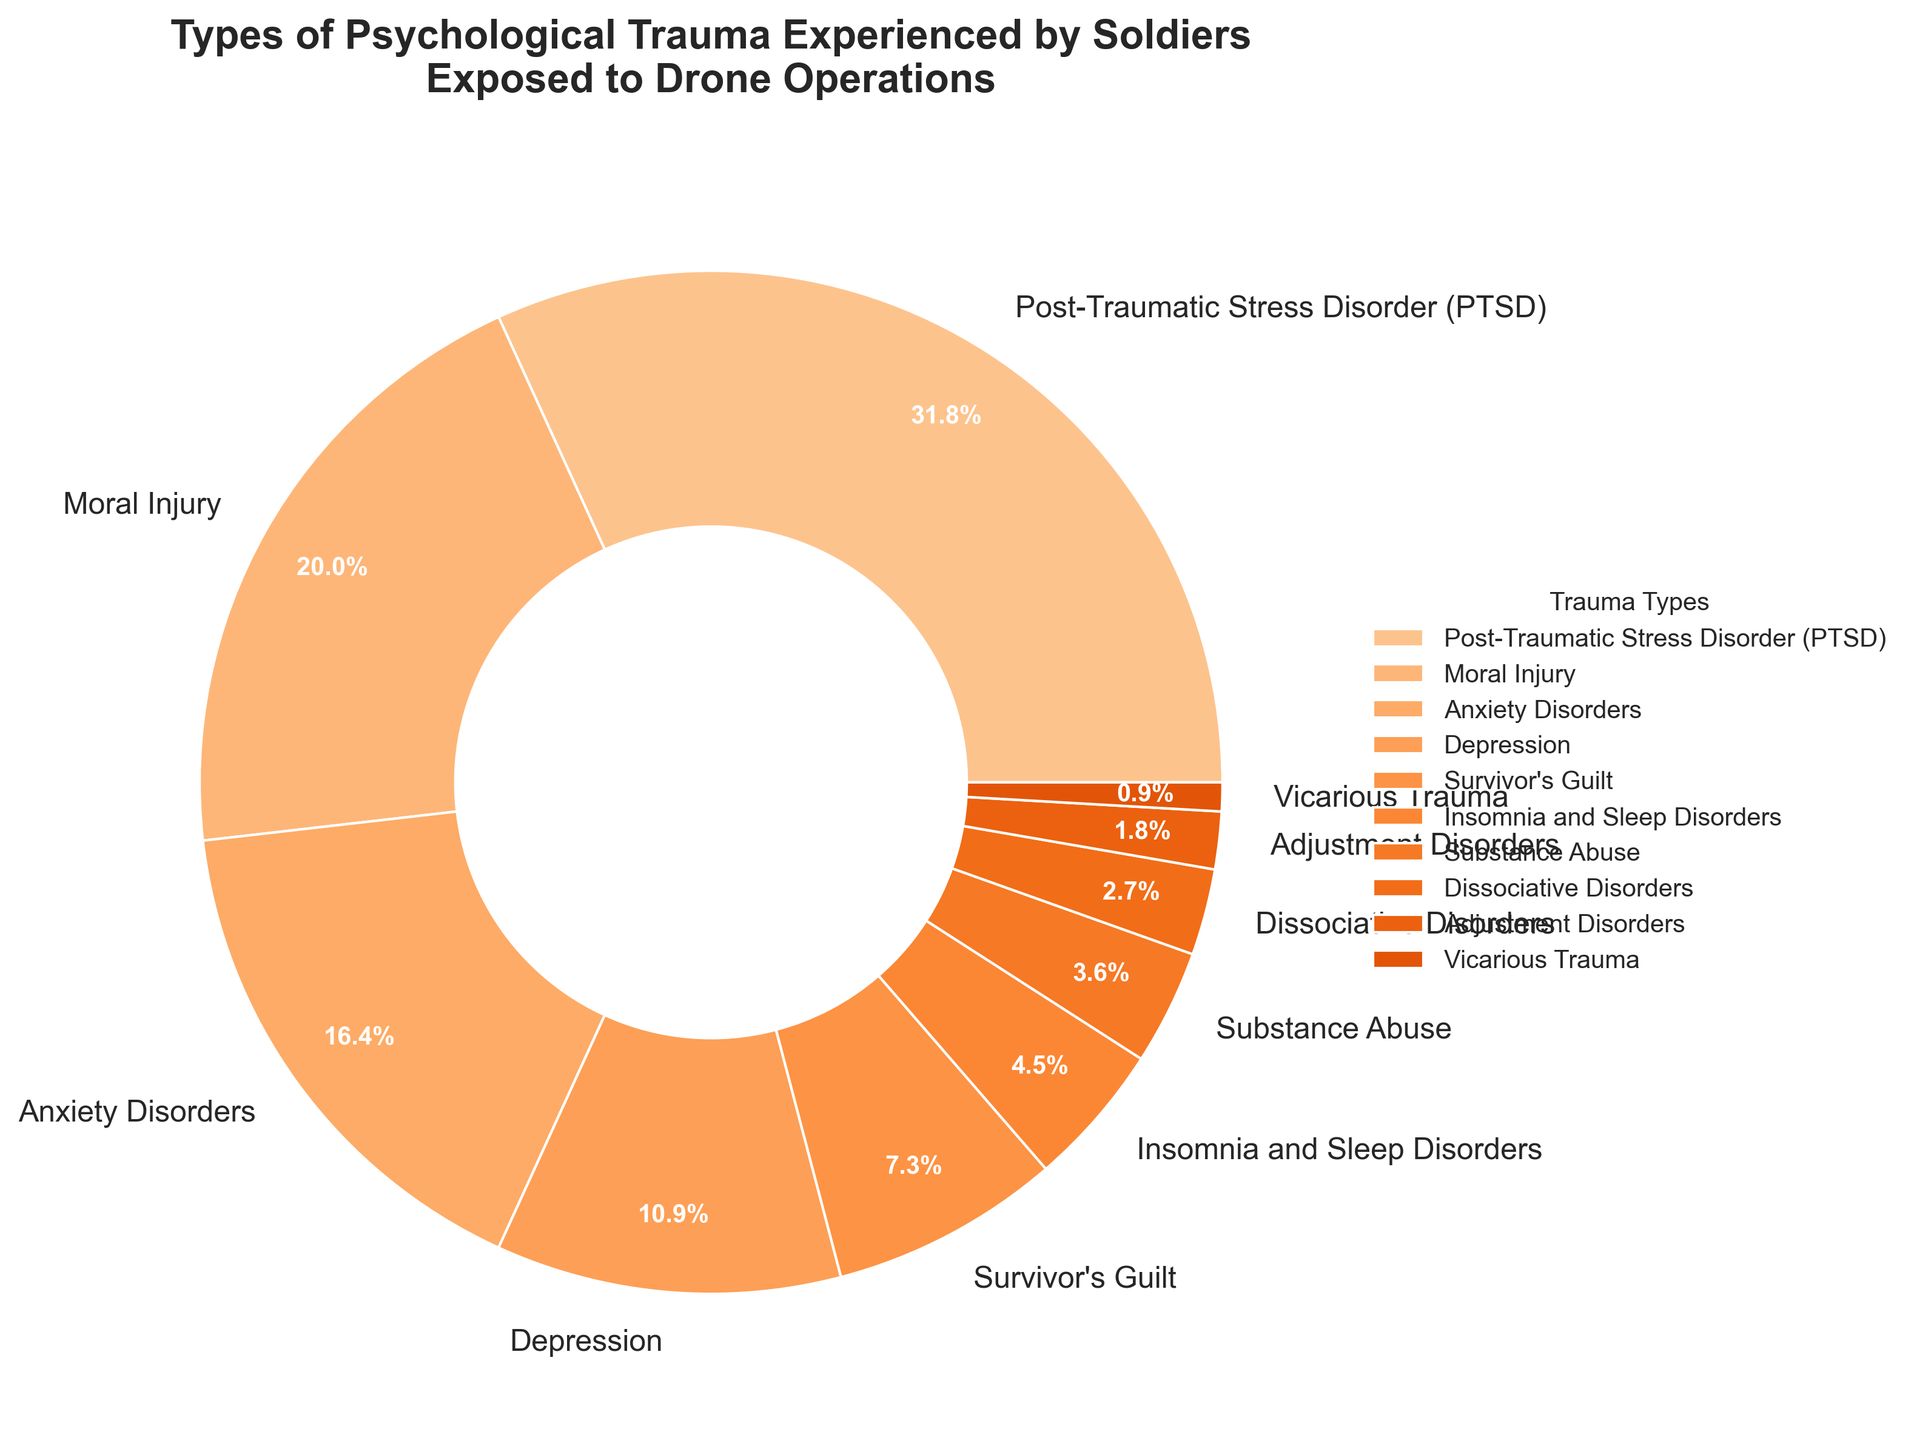Which type of psychological trauma has the highest percentage? By examining the pie chart, it is evident which trauma type is represented by the largest segment. This largest segment corresponds to "Post-Traumatic Stress Disorder (PTSD)" with a percentage of 35%.
Answer: Post-Traumatic Stress Disorder (PTSD) What is the combined percentage of Anxiety Disorders and Depression? Referring to the pie chart for Anxiety Disorders (18%) and Depression (12%), we sum these two percentages: 18% + 12% = 30%.
Answer: 30% Which trauma has a lower percentage: Substance Abuse or Dissociative Disorders? By comparing their respective segments in the pie chart, Substance Abuse is 4% while Dissociative Disorders is 3%. Dissociative Disorders has a lower percentage.
Answer: Dissociative Disorders How much higher is the percentage of Moral Injury compared to Survivor's Guilt? Looking at the values for Moral Injury (22%) and Survivor's Guilt (8%), the difference is calculated as 22% - 8% = 14%.
Answer: 14% Is the percentage of Moral Injury greater than the sum of Vicarious Trauma and Adjustment Disorders? By summing Vicarious Trauma (1%) and Adjustment Disorders (2%), we get 3%. Since Moral Injury is 22%, it is greater than 3%.
Answer: Yes Which types of trauma have percentages under 5%? By examining the pie chart, the trauma types with percentages under 5% are Insomnia and Sleep Disorders (5%), Substance Abuse (4%), Dissociative Disorders (3%), Adjustment Disorders (2%), and Vicarious Trauma (1%).
Answer: Insomnia and Sleep Disorders, Substance Abuse, Dissociative Disorders, Adjustment Disorders, Vicarious Trauma What is the difference in percentage between PTSD and Anxiety Disorders? The percentage for PTSD is 35% and for Anxiety Disorders is 18%. The difference is calculated as 35% - 18% = 17%.
Answer: 17% Which trauma types combined make up approximately half of all cases? Adding the percentages of PTSD (35%) and Moral Injury (22%), we get 57%, which is over half. Instead, combining PTSD (35%) and Anxiety Disorders (18%) yields 53%, which is closer to half but slightly over. Combining PTSD (35%) and Moral Injury (22%) is acceptable as these two combined make up a significant portion (~over half).
Answer: PTSD and Moral Injury 